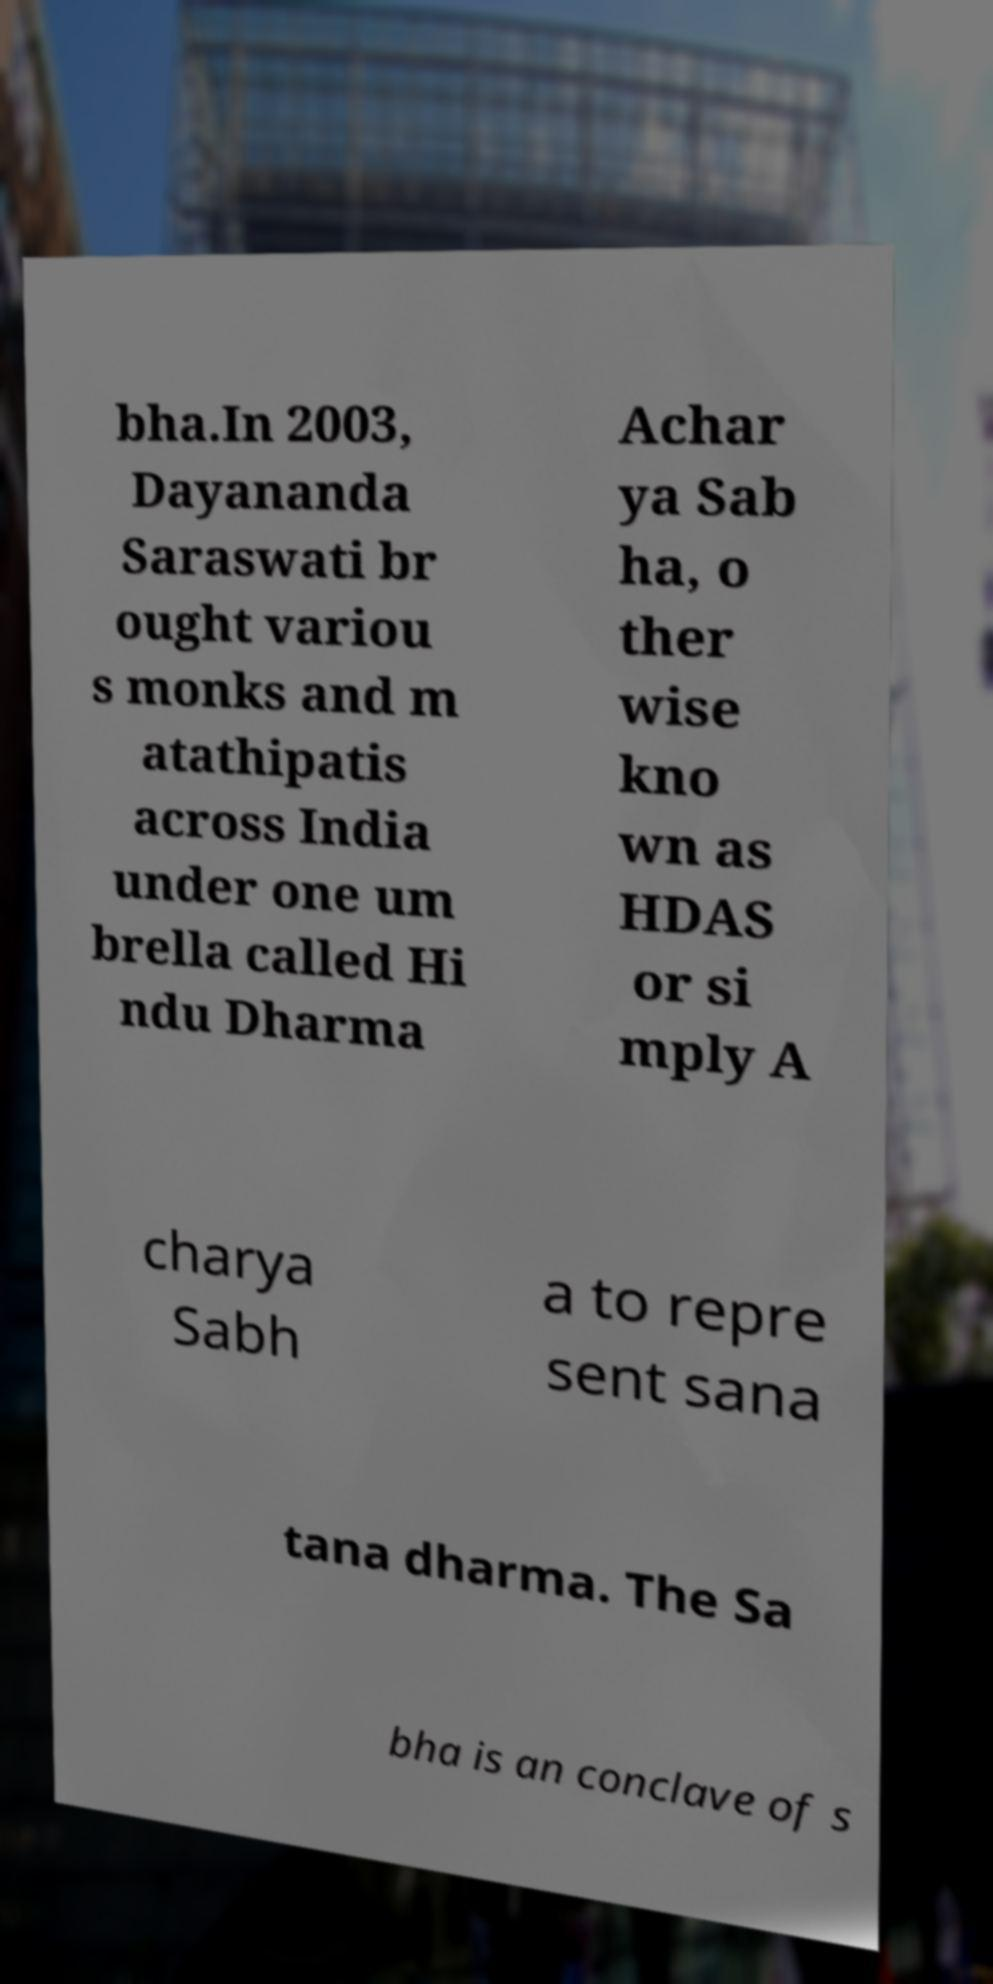For documentation purposes, I need the text within this image transcribed. Could you provide that? bha.In 2003, Dayananda Saraswati br ought variou s monks and m atathipatis across India under one um brella called Hi ndu Dharma Achar ya Sab ha, o ther wise kno wn as HDAS or si mply A charya Sabh a to repre sent sana tana dharma. The Sa bha is an conclave of s 